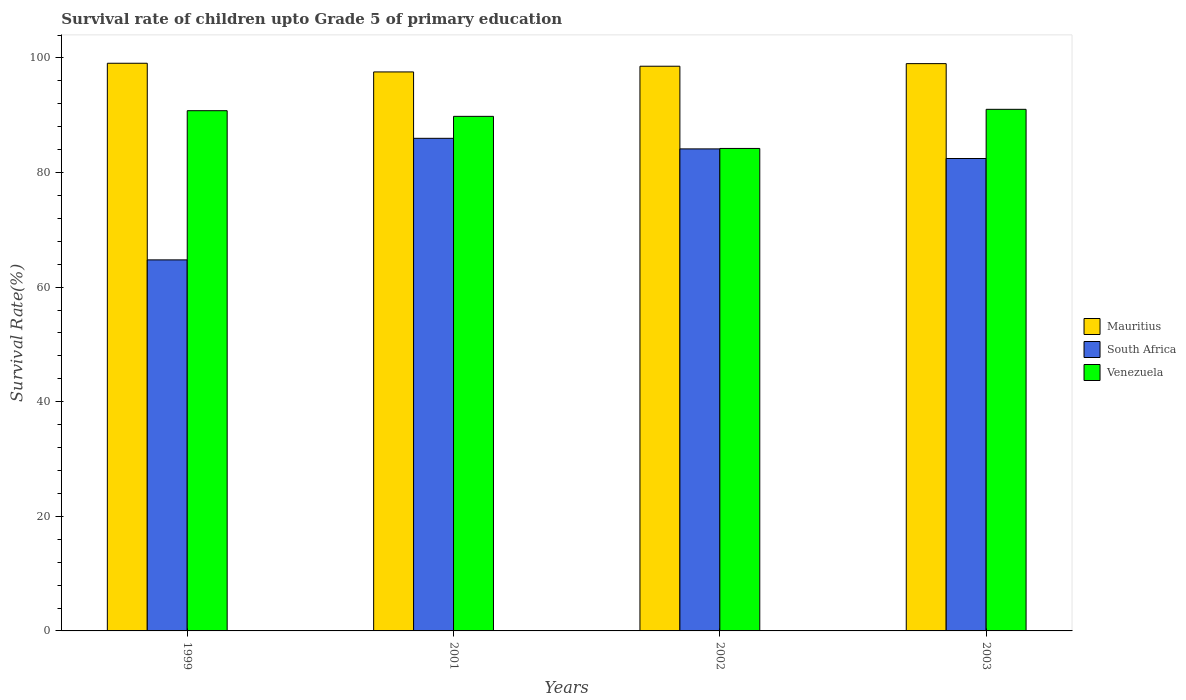How many different coloured bars are there?
Give a very brief answer. 3. How many bars are there on the 1st tick from the left?
Your answer should be compact. 3. What is the label of the 1st group of bars from the left?
Give a very brief answer. 1999. What is the survival rate of children in South Africa in 2003?
Keep it short and to the point. 82.45. Across all years, what is the maximum survival rate of children in Mauritius?
Make the answer very short. 99.08. Across all years, what is the minimum survival rate of children in South Africa?
Ensure brevity in your answer.  64.76. What is the total survival rate of children in Venezuela in the graph?
Provide a short and direct response. 355.85. What is the difference between the survival rate of children in South Africa in 1999 and that in 2003?
Give a very brief answer. -17.69. What is the difference between the survival rate of children in Mauritius in 2002 and the survival rate of children in South Africa in 1999?
Offer a very short reply. 33.8. What is the average survival rate of children in Mauritius per year?
Your response must be concise. 98.55. In the year 2001, what is the difference between the survival rate of children in South Africa and survival rate of children in Mauritius?
Give a very brief answer. -11.59. In how many years, is the survival rate of children in Venezuela greater than 40 %?
Keep it short and to the point. 4. What is the ratio of the survival rate of children in Mauritius in 1999 to that in 2001?
Ensure brevity in your answer.  1.02. Is the survival rate of children in Venezuela in 2001 less than that in 2003?
Your response must be concise. Yes. Is the difference between the survival rate of children in South Africa in 2002 and 2003 greater than the difference between the survival rate of children in Mauritius in 2002 and 2003?
Your answer should be very brief. Yes. What is the difference between the highest and the second highest survival rate of children in Venezuela?
Keep it short and to the point. 0.24. What is the difference between the highest and the lowest survival rate of children in Mauritius?
Make the answer very short. 1.51. In how many years, is the survival rate of children in Mauritius greater than the average survival rate of children in Mauritius taken over all years?
Provide a succinct answer. 3. Is the sum of the survival rate of children in South Africa in 2002 and 2003 greater than the maximum survival rate of children in Venezuela across all years?
Your answer should be compact. Yes. What does the 3rd bar from the left in 2002 represents?
Your response must be concise. Venezuela. What does the 1st bar from the right in 2001 represents?
Offer a very short reply. Venezuela. Are all the bars in the graph horizontal?
Offer a very short reply. No. What is the difference between two consecutive major ticks on the Y-axis?
Ensure brevity in your answer.  20. Are the values on the major ticks of Y-axis written in scientific E-notation?
Provide a short and direct response. No. Does the graph contain any zero values?
Provide a succinct answer. No. Does the graph contain grids?
Your answer should be very brief. No. Where does the legend appear in the graph?
Your answer should be compact. Center right. How many legend labels are there?
Offer a terse response. 3. What is the title of the graph?
Keep it short and to the point. Survival rate of children upto Grade 5 of primary education. What is the label or title of the X-axis?
Keep it short and to the point. Years. What is the label or title of the Y-axis?
Give a very brief answer. Survival Rate(%). What is the Survival Rate(%) of Mauritius in 1999?
Provide a succinct answer. 99.08. What is the Survival Rate(%) in South Africa in 1999?
Offer a very short reply. 64.76. What is the Survival Rate(%) in Venezuela in 1999?
Your answer should be compact. 90.8. What is the Survival Rate(%) of Mauritius in 2001?
Keep it short and to the point. 97.56. What is the Survival Rate(%) of South Africa in 2001?
Offer a very short reply. 85.97. What is the Survival Rate(%) of Venezuela in 2001?
Provide a succinct answer. 89.81. What is the Survival Rate(%) of Mauritius in 2002?
Provide a succinct answer. 98.56. What is the Survival Rate(%) in South Africa in 2002?
Keep it short and to the point. 84.13. What is the Survival Rate(%) in Venezuela in 2002?
Offer a terse response. 84.21. What is the Survival Rate(%) of Mauritius in 2003?
Offer a very short reply. 99.01. What is the Survival Rate(%) of South Africa in 2003?
Provide a succinct answer. 82.45. What is the Survival Rate(%) of Venezuela in 2003?
Provide a succinct answer. 91.03. Across all years, what is the maximum Survival Rate(%) of Mauritius?
Offer a very short reply. 99.08. Across all years, what is the maximum Survival Rate(%) in South Africa?
Offer a terse response. 85.97. Across all years, what is the maximum Survival Rate(%) in Venezuela?
Make the answer very short. 91.03. Across all years, what is the minimum Survival Rate(%) in Mauritius?
Your response must be concise. 97.56. Across all years, what is the minimum Survival Rate(%) of South Africa?
Keep it short and to the point. 64.76. Across all years, what is the minimum Survival Rate(%) of Venezuela?
Your response must be concise. 84.21. What is the total Survival Rate(%) of Mauritius in the graph?
Your answer should be very brief. 394.2. What is the total Survival Rate(%) of South Africa in the graph?
Ensure brevity in your answer.  317.31. What is the total Survival Rate(%) of Venezuela in the graph?
Your response must be concise. 355.85. What is the difference between the Survival Rate(%) in Mauritius in 1999 and that in 2001?
Provide a succinct answer. 1.51. What is the difference between the Survival Rate(%) of South Africa in 1999 and that in 2001?
Provide a short and direct response. -21.22. What is the difference between the Survival Rate(%) of Venezuela in 1999 and that in 2001?
Make the answer very short. 0.99. What is the difference between the Survival Rate(%) of Mauritius in 1999 and that in 2002?
Provide a short and direct response. 0.52. What is the difference between the Survival Rate(%) in South Africa in 1999 and that in 2002?
Offer a terse response. -19.37. What is the difference between the Survival Rate(%) of Venezuela in 1999 and that in 2002?
Your answer should be compact. 6.59. What is the difference between the Survival Rate(%) of Mauritius in 1999 and that in 2003?
Provide a succinct answer. 0.07. What is the difference between the Survival Rate(%) of South Africa in 1999 and that in 2003?
Offer a very short reply. -17.69. What is the difference between the Survival Rate(%) of Venezuela in 1999 and that in 2003?
Offer a very short reply. -0.24. What is the difference between the Survival Rate(%) of Mauritius in 2001 and that in 2002?
Keep it short and to the point. -1. What is the difference between the Survival Rate(%) in South Africa in 2001 and that in 2002?
Keep it short and to the point. 1.85. What is the difference between the Survival Rate(%) in Venezuela in 2001 and that in 2002?
Your response must be concise. 5.6. What is the difference between the Survival Rate(%) of Mauritius in 2001 and that in 2003?
Give a very brief answer. -1.45. What is the difference between the Survival Rate(%) of South Africa in 2001 and that in 2003?
Keep it short and to the point. 3.52. What is the difference between the Survival Rate(%) of Venezuela in 2001 and that in 2003?
Make the answer very short. -1.23. What is the difference between the Survival Rate(%) of Mauritius in 2002 and that in 2003?
Provide a short and direct response. -0.45. What is the difference between the Survival Rate(%) of South Africa in 2002 and that in 2003?
Ensure brevity in your answer.  1.68. What is the difference between the Survival Rate(%) in Venezuela in 2002 and that in 2003?
Offer a terse response. -6.83. What is the difference between the Survival Rate(%) in Mauritius in 1999 and the Survival Rate(%) in South Africa in 2001?
Make the answer very short. 13.1. What is the difference between the Survival Rate(%) of Mauritius in 1999 and the Survival Rate(%) of Venezuela in 2001?
Make the answer very short. 9.27. What is the difference between the Survival Rate(%) of South Africa in 1999 and the Survival Rate(%) of Venezuela in 2001?
Offer a very short reply. -25.05. What is the difference between the Survival Rate(%) of Mauritius in 1999 and the Survival Rate(%) of South Africa in 2002?
Provide a succinct answer. 14.95. What is the difference between the Survival Rate(%) of Mauritius in 1999 and the Survival Rate(%) of Venezuela in 2002?
Provide a short and direct response. 14.87. What is the difference between the Survival Rate(%) of South Africa in 1999 and the Survival Rate(%) of Venezuela in 2002?
Your answer should be very brief. -19.45. What is the difference between the Survival Rate(%) in Mauritius in 1999 and the Survival Rate(%) in South Africa in 2003?
Give a very brief answer. 16.62. What is the difference between the Survival Rate(%) of Mauritius in 1999 and the Survival Rate(%) of Venezuela in 2003?
Your answer should be very brief. 8.04. What is the difference between the Survival Rate(%) in South Africa in 1999 and the Survival Rate(%) in Venezuela in 2003?
Offer a very short reply. -26.28. What is the difference between the Survival Rate(%) in Mauritius in 2001 and the Survival Rate(%) in South Africa in 2002?
Provide a short and direct response. 13.43. What is the difference between the Survival Rate(%) in Mauritius in 2001 and the Survival Rate(%) in Venezuela in 2002?
Provide a succinct answer. 13.35. What is the difference between the Survival Rate(%) of South Africa in 2001 and the Survival Rate(%) of Venezuela in 2002?
Your response must be concise. 1.77. What is the difference between the Survival Rate(%) of Mauritius in 2001 and the Survival Rate(%) of South Africa in 2003?
Make the answer very short. 15.11. What is the difference between the Survival Rate(%) of Mauritius in 2001 and the Survival Rate(%) of Venezuela in 2003?
Your answer should be compact. 6.53. What is the difference between the Survival Rate(%) of South Africa in 2001 and the Survival Rate(%) of Venezuela in 2003?
Provide a succinct answer. -5.06. What is the difference between the Survival Rate(%) in Mauritius in 2002 and the Survival Rate(%) in South Africa in 2003?
Make the answer very short. 16.11. What is the difference between the Survival Rate(%) of Mauritius in 2002 and the Survival Rate(%) of Venezuela in 2003?
Give a very brief answer. 7.52. What is the difference between the Survival Rate(%) in South Africa in 2002 and the Survival Rate(%) in Venezuela in 2003?
Provide a succinct answer. -6.91. What is the average Survival Rate(%) in Mauritius per year?
Your answer should be compact. 98.55. What is the average Survival Rate(%) in South Africa per year?
Your response must be concise. 79.33. What is the average Survival Rate(%) of Venezuela per year?
Your response must be concise. 88.96. In the year 1999, what is the difference between the Survival Rate(%) in Mauritius and Survival Rate(%) in South Africa?
Make the answer very short. 34.32. In the year 1999, what is the difference between the Survival Rate(%) of Mauritius and Survival Rate(%) of Venezuela?
Your answer should be compact. 8.28. In the year 1999, what is the difference between the Survival Rate(%) in South Africa and Survival Rate(%) in Venezuela?
Keep it short and to the point. -26.04. In the year 2001, what is the difference between the Survival Rate(%) in Mauritius and Survival Rate(%) in South Africa?
Give a very brief answer. 11.59. In the year 2001, what is the difference between the Survival Rate(%) in Mauritius and Survival Rate(%) in Venezuela?
Offer a terse response. 7.75. In the year 2001, what is the difference between the Survival Rate(%) of South Africa and Survival Rate(%) of Venezuela?
Give a very brief answer. -3.83. In the year 2002, what is the difference between the Survival Rate(%) in Mauritius and Survival Rate(%) in South Africa?
Your response must be concise. 14.43. In the year 2002, what is the difference between the Survival Rate(%) in Mauritius and Survival Rate(%) in Venezuela?
Ensure brevity in your answer.  14.35. In the year 2002, what is the difference between the Survival Rate(%) of South Africa and Survival Rate(%) of Venezuela?
Provide a short and direct response. -0.08. In the year 2003, what is the difference between the Survival Rate(%) in Mauritius and Survival Rate(%) in South Africa?
Give a very brief answer. 16.56. In the year 2003, what is the difference between the Survival Rate(%) of Mauritius and Survival Rate(%) of Venezuela?
Ensure brevity in your answer.  7.97. In the year 2003, what is the difference between the Survival Rate(%) of South Africa and Survival Rate(%) of Venezuela?
Your answer should be very brief. -8.58. What is the ratio of the Survival Rate(%) of Mauritius in 1999 to that in 2001?
Ensure brevity in your answer.  1.02. What is the ratio of the Survival Rate(%) of South Africa in 1999 to that in 2001?
Give a very brief answer. 0.75. What is the ratio of the Survival Rate(%) of Venezuela in 1999 to that in 2001?
Your response must be concise. 1.01. What is the ratio of the Survival Rate(%) of Mauritius in 1999 to that in 2002?
Your answer should be very brief. 1.01. What is the ratio of the Survival Rate(%) of South Africa in 1999 to that in 2002?
Your answer should be compact. 0.77. What is the ratio of the Survival Rate(%) of Venezuela in 1999 to that in 2002?
Offer a very short reply. 1.08. What is the ratio of the Survival Rate(%) in Mauritius in 1999 to that in 2003?
Your answer should be compact. 1. What is the ratio of the Survival Rate(%) in South Africa in 1999 to that in 2003?
Offer a terse response. 0.79. What is the ratio of the Survival Rate(%) of South Africa in 2001 to that in 2002?
Offer a terse response. 1.02. What is the ratio of the Survival Rate(%) of Venezuela in 2001 to that in 2002?
Provide a succinct answer. 1.07. What is the ratio of the Survival Rate(%) of Mauritius in 2001 to that in 2003?
Make the answer very short. 0.99. What is the ratio of the Survival Rate(%) in South Africa in 2001 to that in 2003?
Offer a very short reply. 1.04. What is the ratio of the Survival Rate(%) in Venezuela in 2001 to that in 2003?
Offer a very short reply. 0.99. What is the ratio of the Survival Rate(%) of Mauritius in 2002 to that in 2003?
Offer a very short reply. 1. What is the ratio of the Survival Rate(%) in South Africa in 2002 to that in 2003?
Give a very brief answer. 1.02. What is the ratio of the Survival Rate(%) in Venezuela in 2002 to that in 2003?
Offer a terse response. 0.93. What is the difference between the highest and the second highest Survival Rate(%) of Mauritius?
Your response must be concise. 0.07. What is the difference between the highest and the second highest Survival Rate(%) in South Africa?
Keep it short and to the point. 1.85. What is the difference between the highest and the second highest Survival Rate(%) in Venezuela?
Offer a very short reply. 0.24. What is the difference between the highest and the lowest Survival Rate(%) in Mauritius?
Ensure brevity in your answer.  1.51. What is the difference between the highest and the lowest Survival Rate(%) in South Africa?
Provide a short and direct response. 21.22. What is the difference between the highest and the lowest Survival Rate(%) in Venezuela?
Provide a short and direct response. 6.83. 